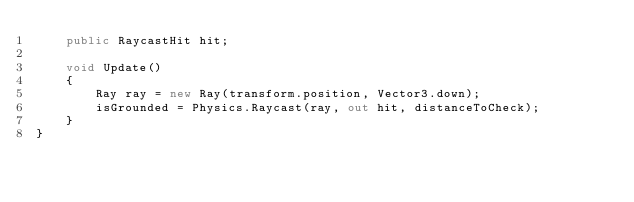Convert code to text. <code><loc_0><loc_0><loc_500><loc_500><_C#_>    public RaycastHit hit;

    void Update()
    {
        Ray ray = new Ray(transform.position, Vector3.down);
        isGrounded = Physics.Raycast(ray, out hit, distanceToCheck);
    }
}
</code> 